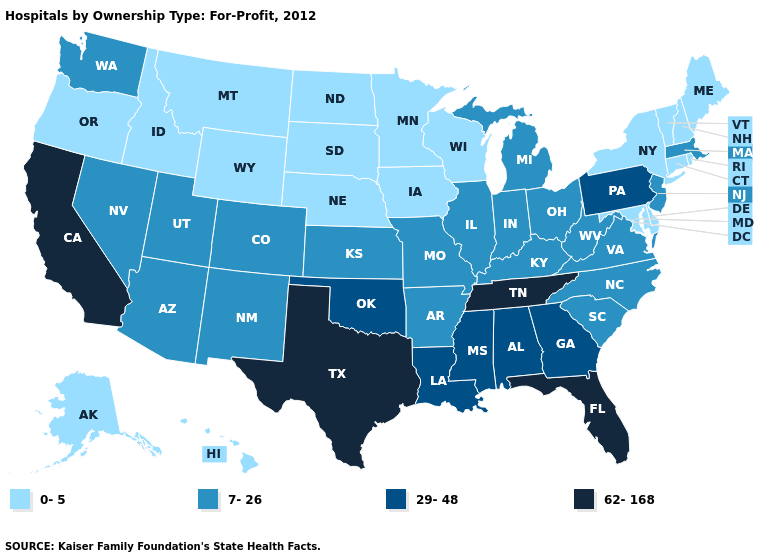Does Florida have the lowest value in the USA?
Answer briefly. No. Among the states that border Arizona , which have the highest value?
Quick response, please. California. Which states have the highest value in the USA?
Quick response, please. California, Florida, Tennessee, Texas. Name the states that have a value in the range 62-168?
Concise answer only. California, Florida, Tennessee, Texas. Name the states that have a value in the range 7-26?
Be succinct. Arizona, Arkansas, Colorado, Illinois, Indiana, Kansas, Kentucky, Massachusetts, Michigan, Missouri, Nevada, New Jersey, New Mexico, North Carolina, Ohio, South Carolina, Utah, Virginia, Washington, West Virginia. Does the map have missing data?
Write a very short answer. No. Name the states that have a value in the range 7-26?
Write a very short answer. Arizona, Arkansas, Colorado, Illinois, Indiana, Kansas, Kentucky, Massachusetts, Michigan, Missouri, Nevada, New Jersey, New Mexico, North Carolina, Ohio, South Carolina, Utah, Virginia, Washington, West Virginia. Which states have the highest value in the USA?
Concise answer only. California, Florida, Tennessee, Texas. What is the highest value in the MidWest ?
Keep it brief. 7-26. What is the value of Louisiana?
Give a very brief answer. 29-48. Does Tennessee have the lowest value in the USA?
Concise answer only. No. Name the states that have a value in the range 0-5?
Answer briefly. Alaska, Connecticut, Delaware, Hawaii, Idaho, Iowa, Maine, Maryland, Minnesota, Montana, Nebraska, New Hampshire, New York, North Dakota, Oregon, Rhode Island, South Dakota, Vermont, Wisconsin, Wyoming. Is the legend a continuous bar?
Keep it brief. No. Among the states that border Kansas , does Missouri have the lowest value?
Concise answer only. No. Does Oregon have the highest value in the USA?
Short answer required. No. 